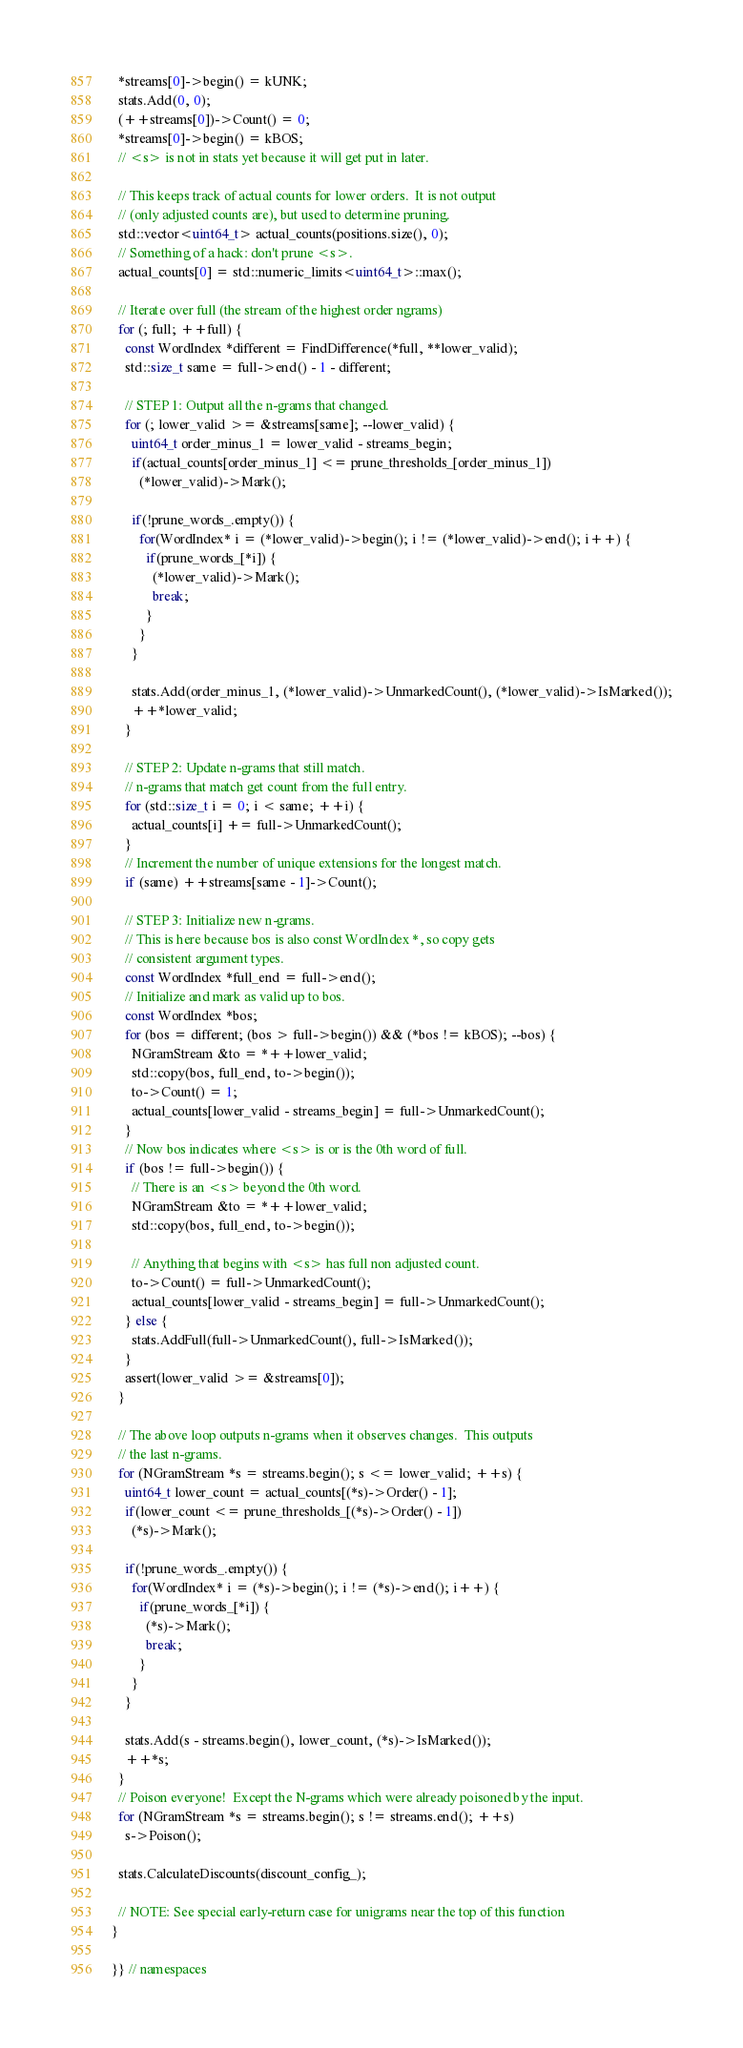Convert code to text. <code><loc_0><loc_0><loc_500><loc_500><_C++_>  *streams[0]->begin() = kUNK;
  stats.Add(0, 0);
  (++streams[0])->Count() = 0;
  *streams[0]->begin() = kBOS;
  // <s> is not in stats yet because it will get put in later.

  // This keeps track of actual counts for lower orders.  It is not output
  // (only adjusted counts are), but used to determine pruning.
  std::vector<uint64_t> actual_counts(positions.size(), 0);
  // Something of a hack: don't prune <s>.
  actual_counts[0] = std::numeric_limits<uint64_t>::max();
  
  // Iterate over full (the stream of the highest order ngrams)
  for (; full; ++full) {
    const WordIndex *different = FindDifference(*full, **lower_valid);
    std::size_t same = full->end() - 1 - different;

    // STEP 1: Output all the n-grams that changed.
    for (; lower_valid >= &streams[same]; --lower_valid) {
      uint64_t order_minus_1 = lower_valid - streams_begin;
      if(actual_counts[order_minus_1] <= prune_thresholds_[order_minus_1])
        (*lower_valid)->Mark();
      
      if(!prune_words_.empty()) {
        for(WordIndex* i = (*lower_valid)->begin(); i != (*lower_valid)->end(); i++) {
          if(prune_words_[*i]) {
            (*lower_valid)->Mark(); 
            break;
          }
        }
      }
        
      stats.Add(order_minus_1, (*lower_valid)->UnmarkedCount(), (*lower_valid)->IsMarked());
      ++*lower_valid;
    }

    // STEP 2: Update n-grams that still match.
    // n-grams that match get count from the full entry.
    for (std::size_t i = 0; i < same; ++i) {
      actual_counts[i] += full->UnmarkedCount();
    }
    // Increment the number of unique extensions for the longest match.
    if (same) ++streams[same - 1]->Count();

    // STEP 3: Initialize new n-grams.
    // This is here because bos is also const WordIndex *, so copy gets
    // consistent argument types.
    const WordIndex *full_end = full->end();
    // Initialize and mark as valid up to bos.
    const WordIndex *bos;
    for (bos = different; (bos > full->begin()) && (*bos != kBOS); --bos) {
      NGramStream &to = *++lower_valid;
      std::copy(bos, full_end, to->begin());
      to->Count() = 1;
      actual_counts[lower_valid - streams_begin] = full->UnmarkedCount();
    }
    // Now bos indicates where <s> is or is the 0th word of full.
    if (bos != full->begin()) {
      // There is an <s> beyond the 0th word.
      NGramStream &to = *++lower_valid;
      std::copy(bos, full_end, to->begin());

      // Anything that begins with <s> has full non adjusted count.
      to->Count() = full->UnmarkedCount();
      actual_counts[lower_valid - streams_begin] = full->UnmarkedCount();
    } else {
      stats.AddFull(full->UnmarkedCount(), full->IsMarked());
    }
    assert(lower_valid >= &streams[0]);
  }

  // The above loop outputs n-grams when it observes changes.  This outputs
  // the last n-grams.
  for (NGramStream *s = streams.begin(); s <= lower_valid; ++s) {
    uint64_t lower_count = actual_counts[(*s)->Order() - 1];
    if(lower_count <= prune_thresholds_[(*s)->Order() - 1])
      (*s)->Mark();
      
    if(!prune_words_.empty()) {
      for(WordIndex* i = (*s)->begin(); i != (*s)->end(); i++) {
        if(prune_words_[*i]) {
          (*s)->Mark(); 
          break;
        }
      }
    }
      
    stats.Add(s - streams.begin(), lower_count, (*s)->IsMarked());
    ++*s;
  }
  // Poison everyone!  Except the N-grams which were already poisoned by the input.
  for (NGramStream *s = streams.begin(); s != streams.end(); ++s)
    s->Poison();

  stats.CalculateDiscounts(discount_config_);

  // NOTE: See special early-return case for unigrams near the top of this function
}

}} // namespaces
</code> 